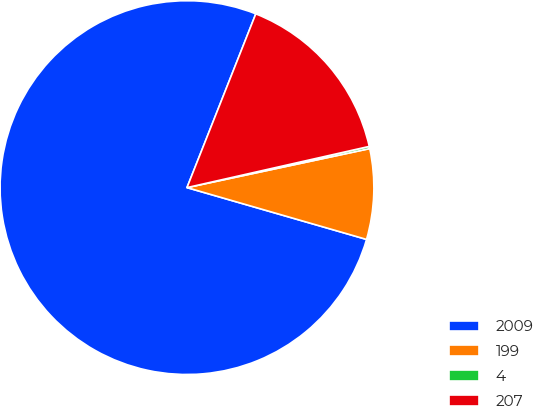Convert chart to OTSL. <chart><loc_0><loc_0><loc_500><loc_500><pie_chart><fcel>2009<fcel>199<fcel>4<fcel>207<nl><fcel>76.53%<fcel>7.82%<fcel>0.19%<fcel>15.46%<nl></chart> 